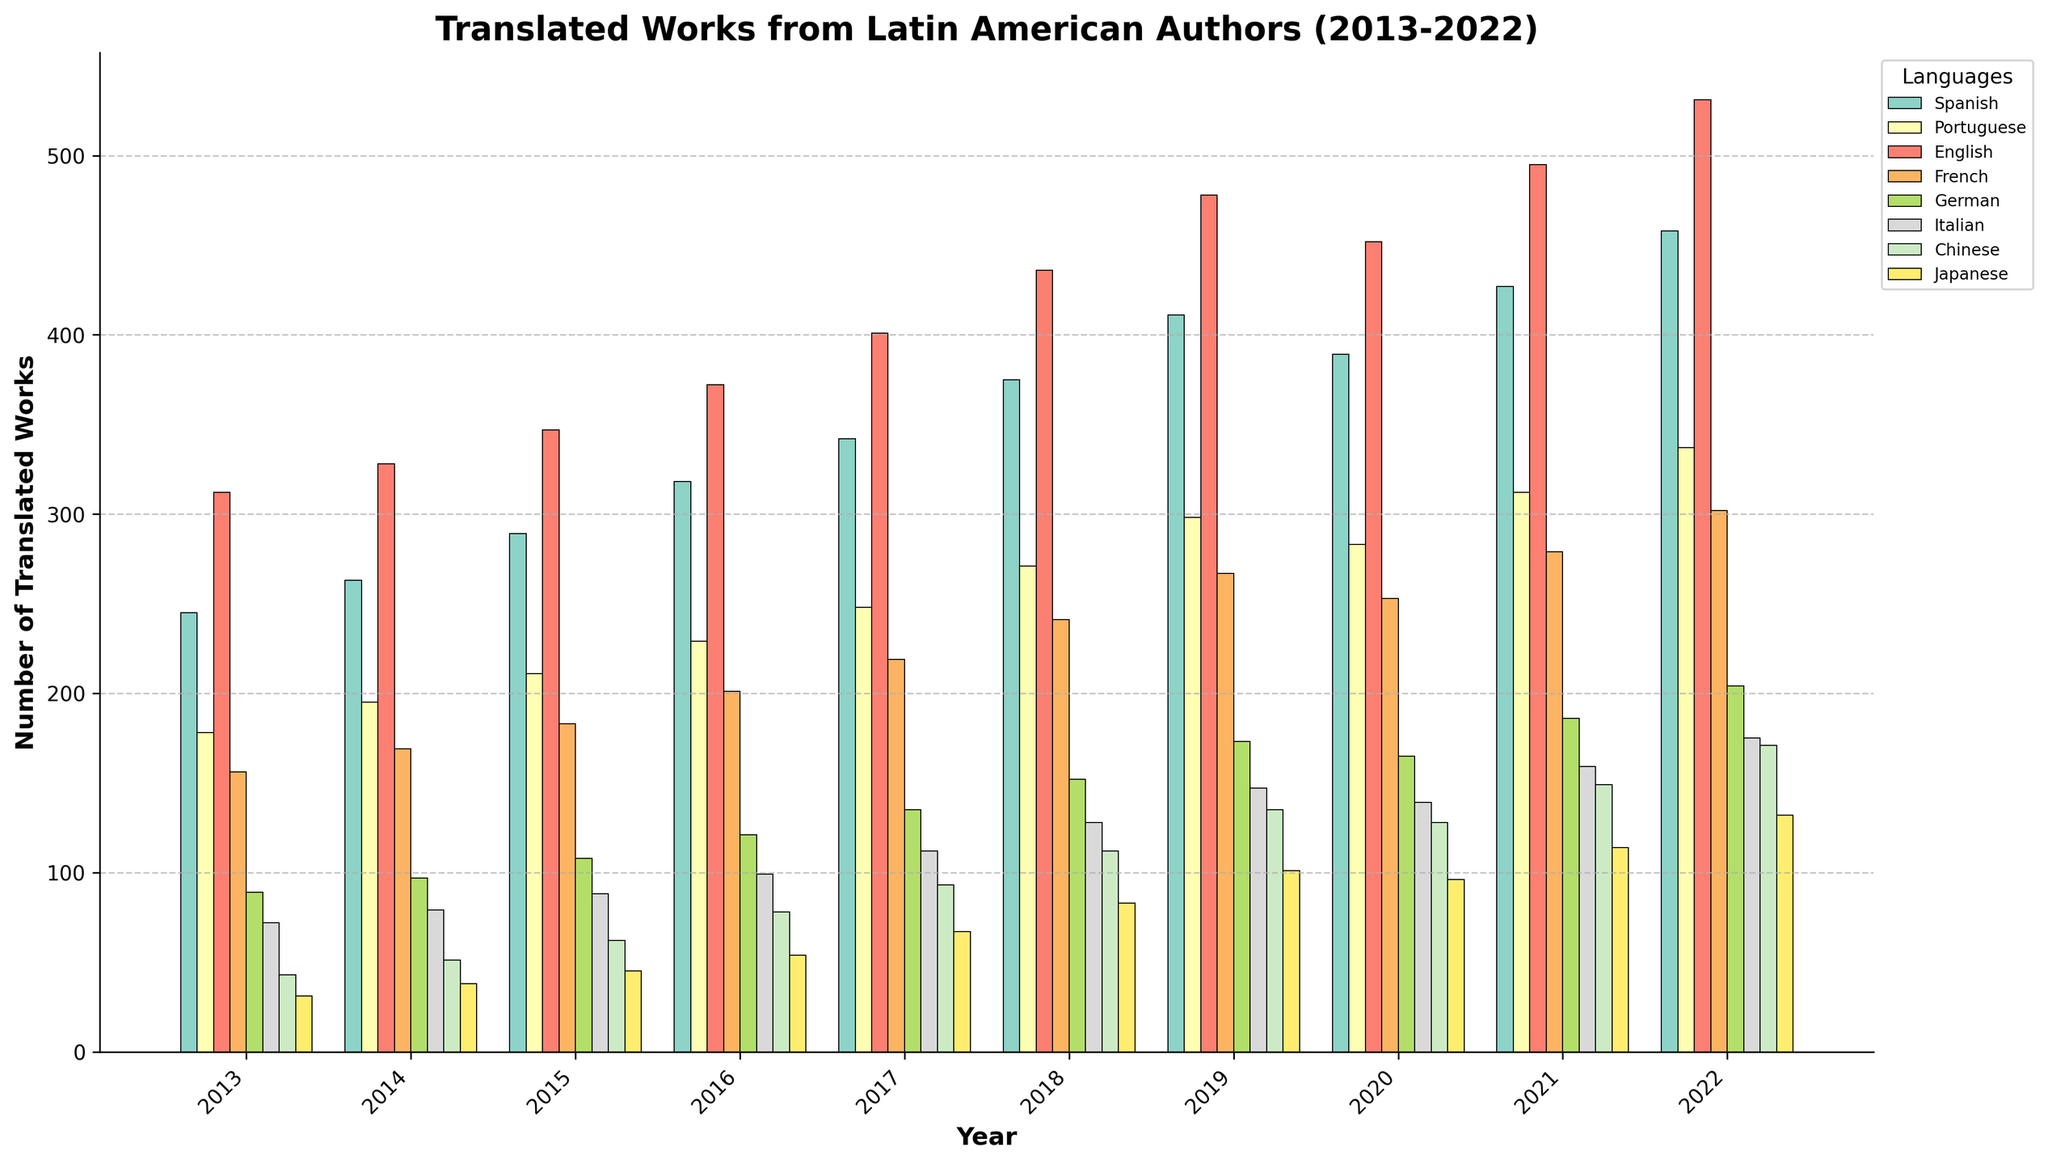What year had the highest number of translated works into English? The year with the highest bar in the "English" series indicates the year with the most translations. From the figure, this is the year 2022.
Answer: 2022 Which language saw the greatest increase in translated works from 2013 to 2022? To find this, we subtract the number of works in 2013 from the number in 2022 for each language and identify the largest increase. English increased from 312 (2013) to 531 (2022), an increase of 219, which is the highest.
Answer: English Among the languages shown, which had the least number of translated works in 2015? By examining the height of the bars in 2015, we identify the shortest bar, which is for Japanese with 45 works.
Answer: Japanese What is the total number of translated works for all languages in 2018? We sum the bars for all languages in 2018: 375 (Spanish) + 271 (Portuguese) + 436 (English) + 241 (French) + 152 (German) + 128 (Italian) + 112 (Chinese) + 83 (Japanese) = 1798.
Answer: 1798 Which year showed the most significant decrease in translated works in German compared to the previous year? By comparing the heights of the "German" bars year-by-year, we see 2020 had a drop from 2019 (173 to 165), a decrease of 8, which is the most significant.
Answer: 2020 How does the number of translated works in French in 2017 compare to Spanish in 2017? Compare the heights of the French and Spanish bars in 2017. French has 219, Spanish has 342, so Spanish has more.
Answer: Spanish has more What were the average translated works into Italian between 2013 and 2017? To find the average: (72 + 79 + 88 + 99 + 112) / 5 = 90.
Answer: 90 Between 2021 and 2022, which language had the smallest increase in translations? By subtracting the 2021 values from the 2022 values for each language, Japanese increased from 114 to 132, an increase of 18, which is the smallest.
Answer: Japanese What languages had more than 400 translated works in 2022? By looking at the height of the bars in 2022, Spanish (458), Portuguese (337), English (531), and French (302). Only English and Spanish exceed 400.
Answer: Spanish, English In what year did translations in Portuguese first exceed 200 works? By examining the bar heights for Portuguese each year, it first exceeds 200 in 2015.
Answer: 2015 